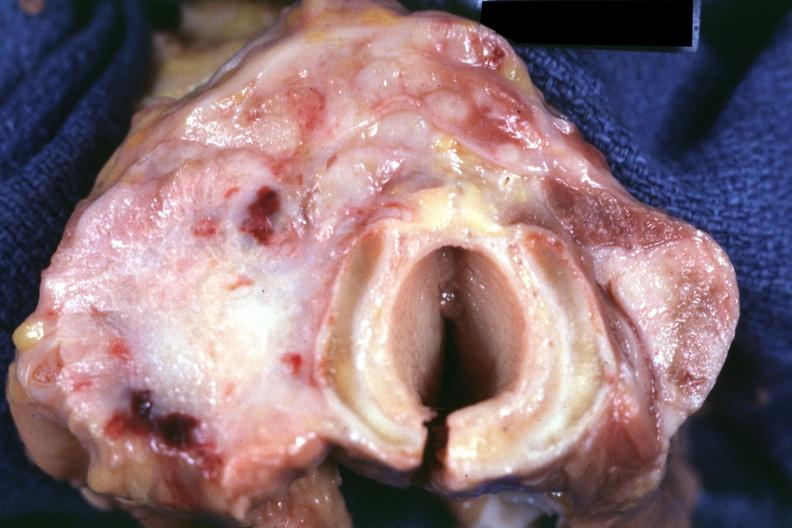how is carcinoma had metastases to lungs , pleura , liver and nodes?
Answer the question using a single word or phrase. Regional 